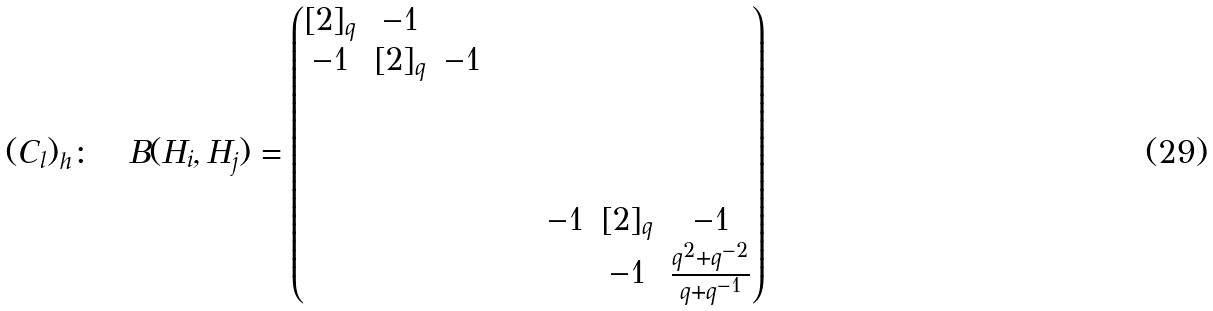<formula> <loc_0><loc_0><loc_500><loc_500>( C _ { l } ) _ { h } \colon \quad B ( H _ { i } , H _ { j } ) = \begin{pmatrix} [ 2 ] _ { q } & - 1 & & & & & & & \\ - 1 & [ 2 ] _ { q } & - 1 & & & & & & \\ & & & & & & & & \\ & & & & & & & & \\ & & & & & & & & \\ & & & & & & - 1 & [ 2 ] _ { q } & - 1 \\ & & & & & & & - 1 & \frac { q ^ { 2 } + q ^ { - 2 } } { q + q ^ { - 1 } } \end{pmatrix}</formula> 